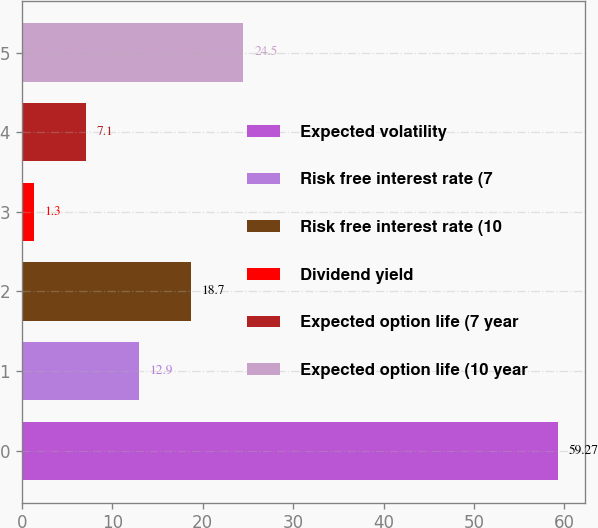Convert chart to OTSL. <chart><loc_0><loc_0><loc_500><loc_500><bar_chart><fcel>Expected volatility<fcel>Risk free interest rate (7<fcel>Risk free interest rate (10<fcel>Dividend yield<fcel>Expected option life (7 year<fcel>Expected option life (10 year<nl><fcel>59.27<fcel>12.9<fcel>18.7<fcel>1.3<fcel>7.1<fcel>24.5<nl></chart> 